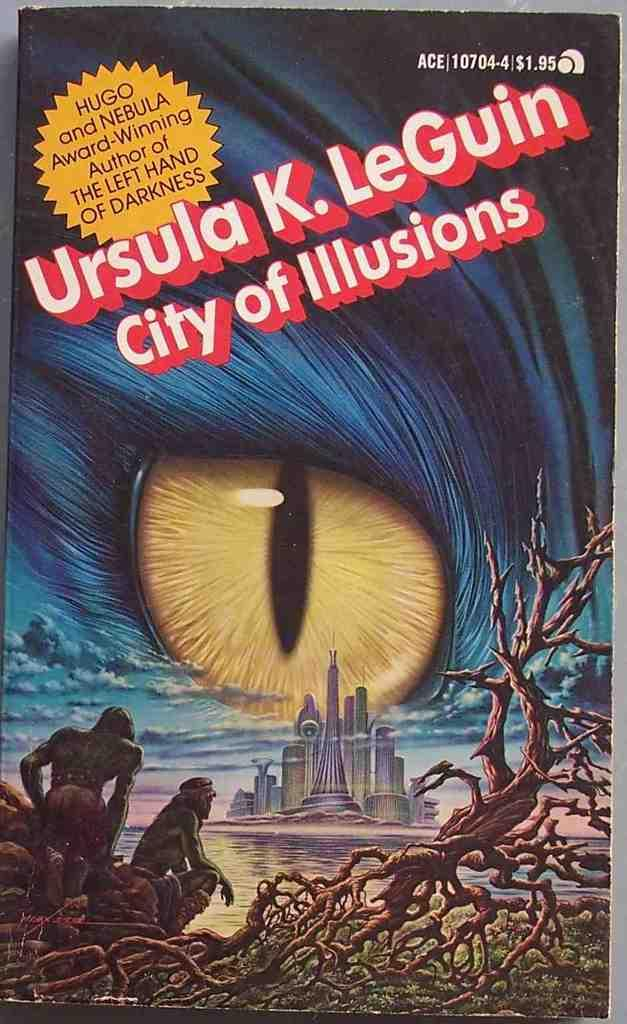<image>
Present a compact description of the photo's key features. A book titled City of Illusions has an eye on the cover. 